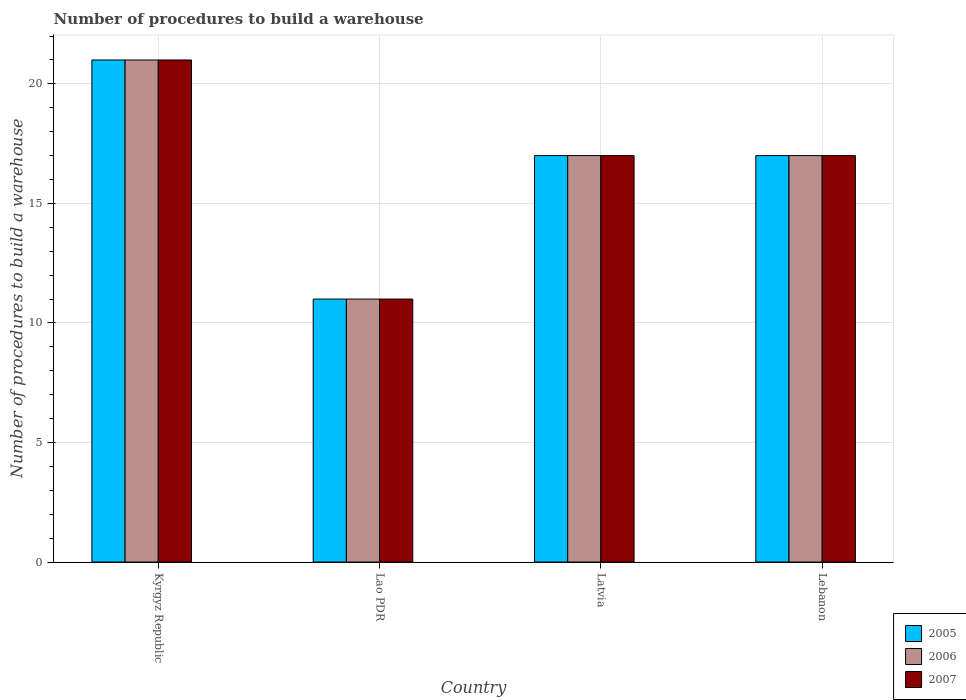How many different coloured bars are there?
Offer a terse response. 3. Are the number of bars per tick equal to the number of legend labels?
Provide a short and direct response. Yes. Are the number of bars on each tick of the X-axis equal?
Offer a terse response. Yes. How many bars are there on the 4th tick from the left?
Your answer should be compact. 3. How many bars are there on the 4th tick from the right?
Your answer should be very brief. 3. What is the label of the 3rd group of bars from the left?
Offer a very short reply. Latvia. In which country was the number of procedures to build a warehouse in in 2005 maximum?
Keep it short and to the point. Kyrgyz Republic. In which country was the number of procedures to build a warehouse in in 2005 minimum?
Keep it short and to the point. Lao PDR. What is the total number of procedures to build a warehouse in in 2005 in the graph?
Offer a very short reply. 66. What is the average number of procedures to build a warehouse in in 2006 per country?
Your response must be concise. 16.5. What is the ratio of the number of procedures to build a warehouse in in 2005 in Kyrgyz Republic to that in Lao PDR?
Offer a very short reply. 1.91. Is the number of procedures to build a warehouse in in 2006 in Kyrgyz Republic less than that in Lao PDR?
Provide a short and direct response. No. In how many countries, is the number of procedures to build a warehouse in in 2006 greater than the average number of procedures to build a warehouse in in 2006 taken over all countries?
Provide a succinct answer. 3. What does the 1st bar from the right in Lebanon represents?
Make the answer very short. 2007. What is the difference between two consecutive major ticks on the Y-axis?
Provide a short and direct response. 5. Does the graph contain grids?
Your answer should be very brief. Yes. Where does the legend appear in the graph?
Make the answer very short. Bottom right. How are the legend labels stacked?
Provide a succinct answer. Vertical. What is the title of the graph?
Offer a terse response. Number of procedures to build a warehouse. What is the label or title of the Y-axis?
Make the answer very short. Number of procedures to build a warehouse. What is the Number of procedures to build a warehouse of 2005 in Kyrgyz Republic?
Your answer should be compact. 21. What is the Number of procedures to build a warehouse of 2007 in Kyrgyz Republic?
Give a very brief answer. 21. What is the Number of procedures to build a warehouse of 2006 in Lao PDR?
Provide a succinct answer. 11. What is the Number of procedures to build a warehouse of 2007 in Lao PDR?
Provide a succinct answer. 11. What is the Number of procedures to build a warehouse of 2007 in Latvia?
Offer a very short reply. 17. What is the Number of procedures to build a warehouse of 2006 in Lebanon?
Offer a very short reply. 17. What is the Number of procedures to build a warehouse of 2007 in Lebanon?
Your answer should be very brief. 17. Across all countries, what is the maximum Number of procedures to build a warehouse of 2005?
Your response must be concise. 21. Across all countries, what is the maximum Number of procedures to build a warehouse of 2007?
Ensure brevity in your answer.  21. Across all countries, what is the minimum Number of procedures to build a warehouse in 2006?
Provide a succinct answer. 11. What is the total Number of procedures to build a warehouse in 2005 in the graph?
Offer a terse response. 66. What is the difference between the Number of procedures to build a warehouse in 2006 in Kyrgyz Republic and that in Lao PDR?
Your answer should be compact. 10. What is the difference between the Number of procedures to build a warehouse of 2005 in Kyrgyz Republic and that in Latvia?
Provide a short and direct response. 4. What is the difference between the Number of procedures to build a warehouse of 2006 in Kyrgyz Republic and that in Latvia?
Offer a very short reply. 4. What is the difference between the Number of procedures to build a warehouse of 2005 in Kyrgyz Republic and that in Lebanon?
Your answer should be very brief. 4. What is the difference between the Number of procedures to build a warehouse of 2007 in Kyrgyz Republic and that in Lebanon?
Provide a succinct answer. 4. What is the difference between the Number of procedures to build a warehouse of 2007 in Lao PDR and that in Latvia?
Offer a terse response. -6. What is the difference between the Number of procedures to build a warehouse in 2006 in Lao PDR and that in Lebanon?
Offer a terse response. -6. What is the difference between the Number of procedures to build a warehouse in 2007 in Lao PDR and that in Lebanon?
Offer a terse response. -6. What is the difference between the Number of procedures to build a warehouse in 2005 in Kyrgyz Republic and the Number of procedures to build a warehouse in 2006 in Lao PDR?
Provide a short and direct response. 10. What is the difference between the Number of procedures to build a warehouse in 2005 in Kyrgyz Republic and the Number of procedures to build a warehouse in 2007 in Lao PDR?
Keep it short and to the point. 10. What is the difference between the Number of procedures to build a warehouse of 2005 in Kyrgyz Republic and the Number of procedures to build a warehouse of 2006 in Latvia?
Keep it short and to the point. 4. What is the difference between the Number of procedures to build a warehouse of 2005 in Kyrgyz Republic and the Number of procedures to build a warehouse of 2007 in Lebanon?
Make the answer very short. 4. What is the difference between the Number of procedures to build a warehouse in 2005 in Lao PDR and the Number of procedures to build a warehouse in 2006 in Latvia?
Offer a very short reply. -6. What is the difference between the Number of procedures to build a warehouse in 2006 in Lao PDR and the Number of procedures to build a warehouse in 2007 in Latvia?
Offer a very short reply. -6. What is the difference between the Number of procedures to build a warehouse of 2005 in Lao PDR and the Number of procedures to build a warehouse of 2006 in Lebanon?
Ensure brevity in your answer.  -6. What is the difference between the Number of procedures to build a warehouse in 2005 in Latvia and the Number of procedures to build a warehouse in 2006 in Lebanon?
Your response must be concise. 0. What is the difference between the Number of procedures to build a warehouse of 2005 and Number of procedures to build a warehouse of 2006 in Kyrgyz Republic?
Offer a terse response. 0. What is the difference between the Number of procedures to build a warehouse in 2006 and Number of procedures to build a warehouse in 2007 in Lebanon?
Your answer should be very brief. 0. What is the ratio of the Number of procedures to build a warehouse of 2005 in Kyrgyz Republic to that in Lao PDR?
Your response must be concise. 1.91. What is the ratio of the Number of procedures to build a warehouse in 2006 in Kyrgyz Republic to that in Lao PDR?
Keep it short and to the point. 1.91. What is the ratio of the Number of procedures to build a warehouse of 2007 in Kyrgyz Republic to that in Lao PDR?
Your answer should be very brief. 1.91. What is the ratio of the Number of procedures to build a warehouse of 2005 in Kyrgyz Republic to that in Latvia?
Ensure brevity in your answer.  1.24. What is the ratio of the Number of procedures to build a warehouse of 2006 in Kyrgyz Republic to that in Latvia?
Offer a terse response. 1.24. What is the ratio of the Number of procedures to build a warehouse in 2007 in Kyrgyz Republic to that in Latvia?
Give a very brief answer. 1.24. What is the ratio of the Number of procedures to build a warehouse in 2005 in Kyrgyz Republic to that in Lebanon?
Provide a short and direct response. 1.24. What is the ratio of the Number of procedures to build a warehouse of 2006 in Kyrgyz Republic to that in Lebanon?
Give a very brief answer. 1.24. What is the ratio of the Number of procedures to build a warehouse in 2007 in Kyrgyz Republic to that in Lebanon?
Your response must be concise. 1.24. What is the ratio of the Number of procedures to build a warehouse of 2005 in Lao PDR to that in Latvia?
Your answer should be compact. 0.65. What is the ratio of the Number of procedures to build a warehouse of 2006 in Lao PDR to that in Latvia?
Give a very brief answer. 0.65. What is the ratio of the Number of procedures to build a warehouse of 2007 in Lao PDR to that in Latvia?
Keep it short and to the point. 0.65. What is the ratio of the Number of procedures to build a warehouse of 2005 in Lao PDR to that in Lebanon?
Your answer should be compact. 0.65. What is the ratio of the Number of procedures to build a warehouse of 2006 in Lao PDR to that in Lebanon?
Make the answer very short. 0.65. What is the ratio of the Number of procedures to build a warehouse of 2007 in Lao PDR to that in Lebanon?
Keep it short and to the point. 0.65. What is the ratio of the Number of procedures to build a warehouse in 2006 in Latvia to that in Lebanon?
Your response must be concise. 1. What is the difference between the highest and the second highest Number of procedures to build a warehouse of 2005?
Offer a very short reply. 4. What is the difference between the highest and the second highest Number of procedures to build a warehouse in 2006?
Offer a very short reply. 4. What is the difference between the highest and the second highest Number of procedures to build a warehouse in 2007?
Your answer should be compact. 4. 